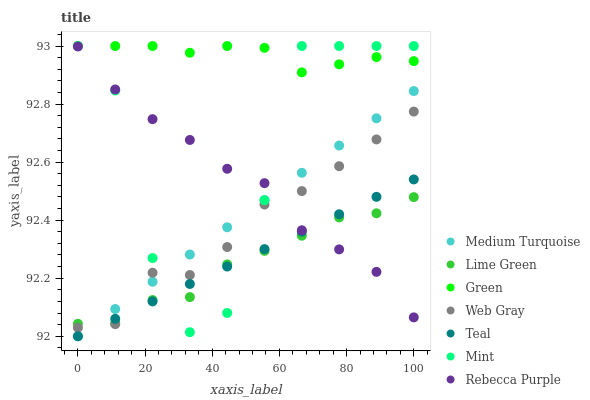Does Lime Green have the minimum area under the curve?
Answer yes or no. Yes. Does Green have the maximum area under the curve?
Answer yes or no. Yes. Does Medium Turquoise have the minimum area under the curve?
Answer yes or no. No. Does Medium Turquoise have the maximum area under the curve?
Answer yes or no. No. Is Medium Turquoise the smoothest?
Answer yes or no. Yes. Is Mint the roughest?
Answer yes or no. Yes. Is Mint the smoothest?
Answer yes or no. No. Is Medium Turquoise the roughest?
Answer yes or no. No. Does Medium Turquoise have the lowest value?
Answer yes or no. Yes. Does Mint have the lowest value?
Answer yes or no. No. Does Green have the highest value?
Answer yes or no. Yes. Does Medium Turquoise have the highest value?
Answer yes or no. No. Is Rebecca Purple less than Green?
Answer yes or no. Yes. Is Green greater than Medium Turquoise?
Answer yes or no. Yes. Does Lime Green intersect Teal?
Answer yes or no. Yes. Is Lime Green less than Teal?
Answer yes or no. No. Is Lime Green greater than Teal?
Answer yes or no. No. Does Rebecca Purple intersect Green?
Answer yes or no. No. 